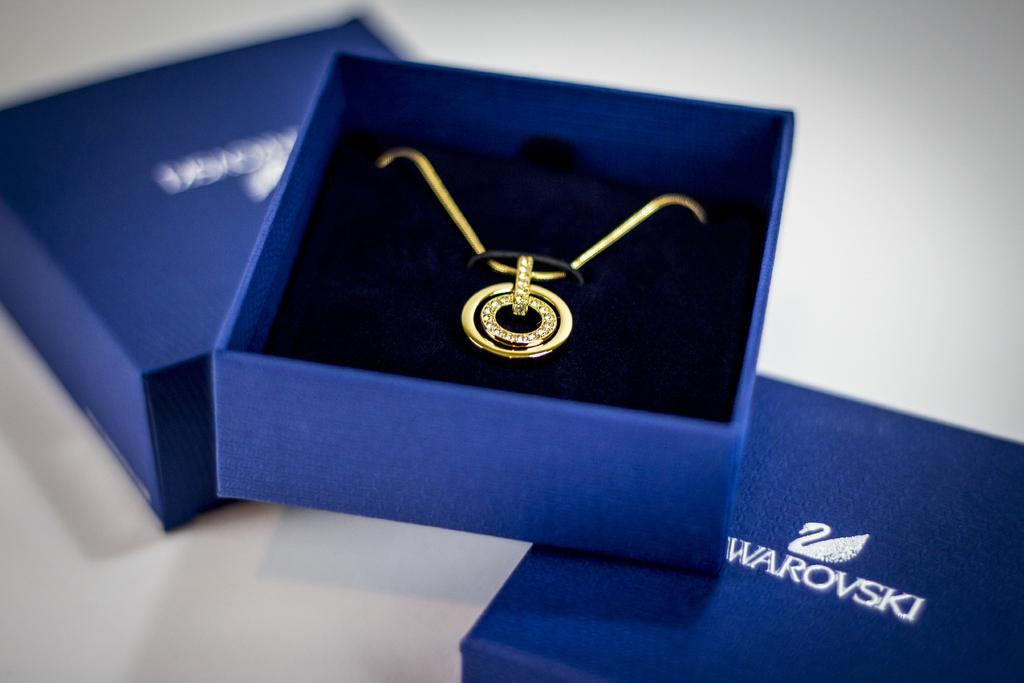<image>
Give a short and clear explanation of the subsequent image. Three Swarovski boxes are shown and one has a piece of gold jewelry showing. 